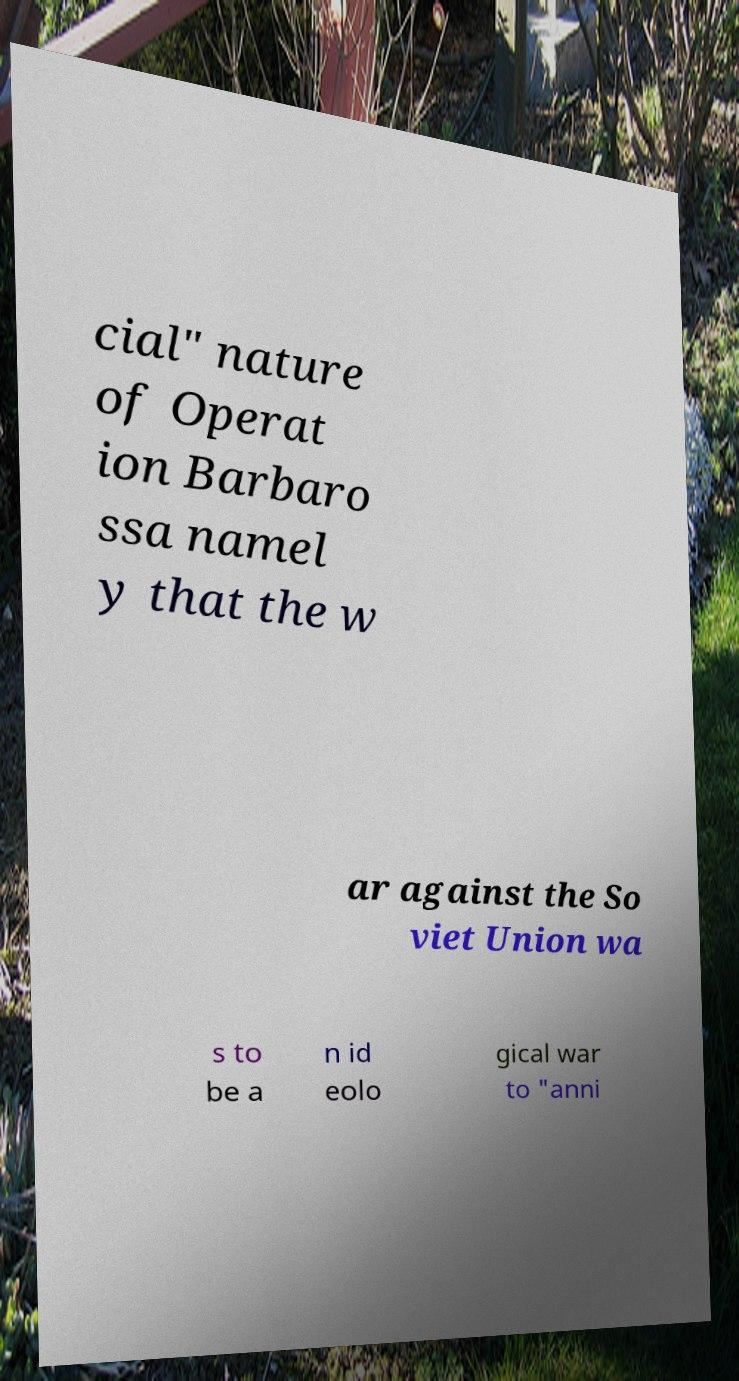Can you read and provide the text displayed in the image?This photo seems to have some interesting text. Can you extract and type it out for me? cial" nature of Operat ion Barbaro ssa namel y that the w ar against the So viet Union wa s to be a n id eolo gical war to "anni 